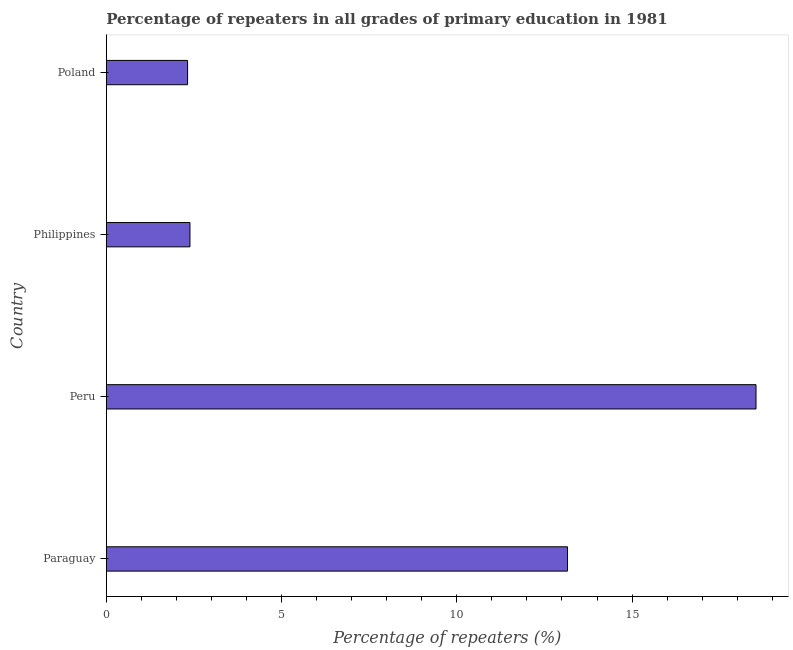Does the graph contain grids?
Give a very brief answer. No. What is the title of the graph?
Your answer should be very brief. Percentage of repeaters in all grades of primary education in 1981. What is the label or title of the X-axis?
Make the answer very short. Percentage of repeaters (%). What is the percentage of repeaters in primary education in Paraguay?
Your answer should be very brief. 13.16. Across all countries, what is the maximum percentage of repeaters in primary education?
Ensure brevity in your answer.  18.54. Across all countries, what is the minimum percentage of repeaters in primary education?
Your answer should be very brief. 2.32. In which country was the percentage of repeaters in primary education minimum?
Offer a terse response. Poland. What is the sum of the percentage of repeaters in primary education?
Your answer should be very brief. 36.4. What is the difference between the percentage of repeaters in primary education in Philippines and Poland?
Provide a succinct answer. 0.07. What is the median percentage of repeaters in primary education?
Keep it short and to the point. 7.77. In how many countries, is the percentage of repeaters in primary education greater than 8 %?
Keep it short and to the point. 2. What is the ratio of the percentage of repeaters in primary education in Peru to that in Philippines?
Offer a terse response. 7.77. What is the difference between the highest and the second highest percentage of repeaters in primary education?
Offer a very short reply. 5.38. Is the sum of the percentage of repeaters in primary education in Philippines and Poland greater than the maximum percentage of repeaters in primary education across all countries?
Your response must be concise. No. What is the difference between the highest and the lowest percentage of repeaters in primary education?
Ensure brevity in your answer.  16.22. How many bars are there?
Offer a very short reply. 4. Are all the bars in the graph horizontal?
Your answer should be very brief. Yes. How many countries are there in the graph?
Provide a succinct answer. 4. Are the values on the major ticks of X-axis written in scientific E-notation?
Keep it short and to the point. No. What is the Percentage of repeaters (%) of Paraguay?
Your response must be concise. 13.16. What is the Percentage of repeaters (%) of Peru?
Make the answer very short. 18.54. What is the Percentage of repeaters (%) of Philippines?
Make the answer very short. 2.39. What is the Percentage of repeaters (%) in Poland?
Give a very brief answer. 2.32. What is the difference between the Percentage of repeaters (%) in Paraguay and Peru?
Ensure brevity in your answer.  -5.38. What is the difference between the Percentage of repeaters (%) in Paraguay and Philippines?
Your answer should be compact. 10.77. What is the difference between the Percentage of repeaters (%) in Paraguay and Poland?
Your answer should be very brief. 10.84. What is the difference between the Percentage of repeaters (%) in Peru and Philippines?
Keep it short and to the point. 16.15. What is the difference between the Percentage of repeaters (%) in Peru and Poland?
Provide a short and direct response. 16.22. What is the difference between the Percentage of repeaters (%) in Philippines and Poland?
Give a very brief answer. 0.07. What is the ratio of the Percentage of repeaters (%) in Paraguay to that in Peru?
Offer a very short reply. 0.71. What is the ratio of the Percentage of repeaters (%) in Paraguay to that in Philippines?
Your answer should be compact. 5.52. What is the ratio of the Percentage of repeaters (%) in Paraguay to that in Poland?
Give a very brief answer. 5.68. What is the ratio of the Percentage of repeaters (%) in Peru to that in Philippines?
Ensure brevity in your answer.  7.77. What is the ratio of the Percentage of repeaters (%) in Peru to that in Poland?
Ensure brevity in your answer.  8. What is the ratio of the Percentage of repeaters (%) in Philippines to that in Poland?
Your answer should be very brief. 1.03. 